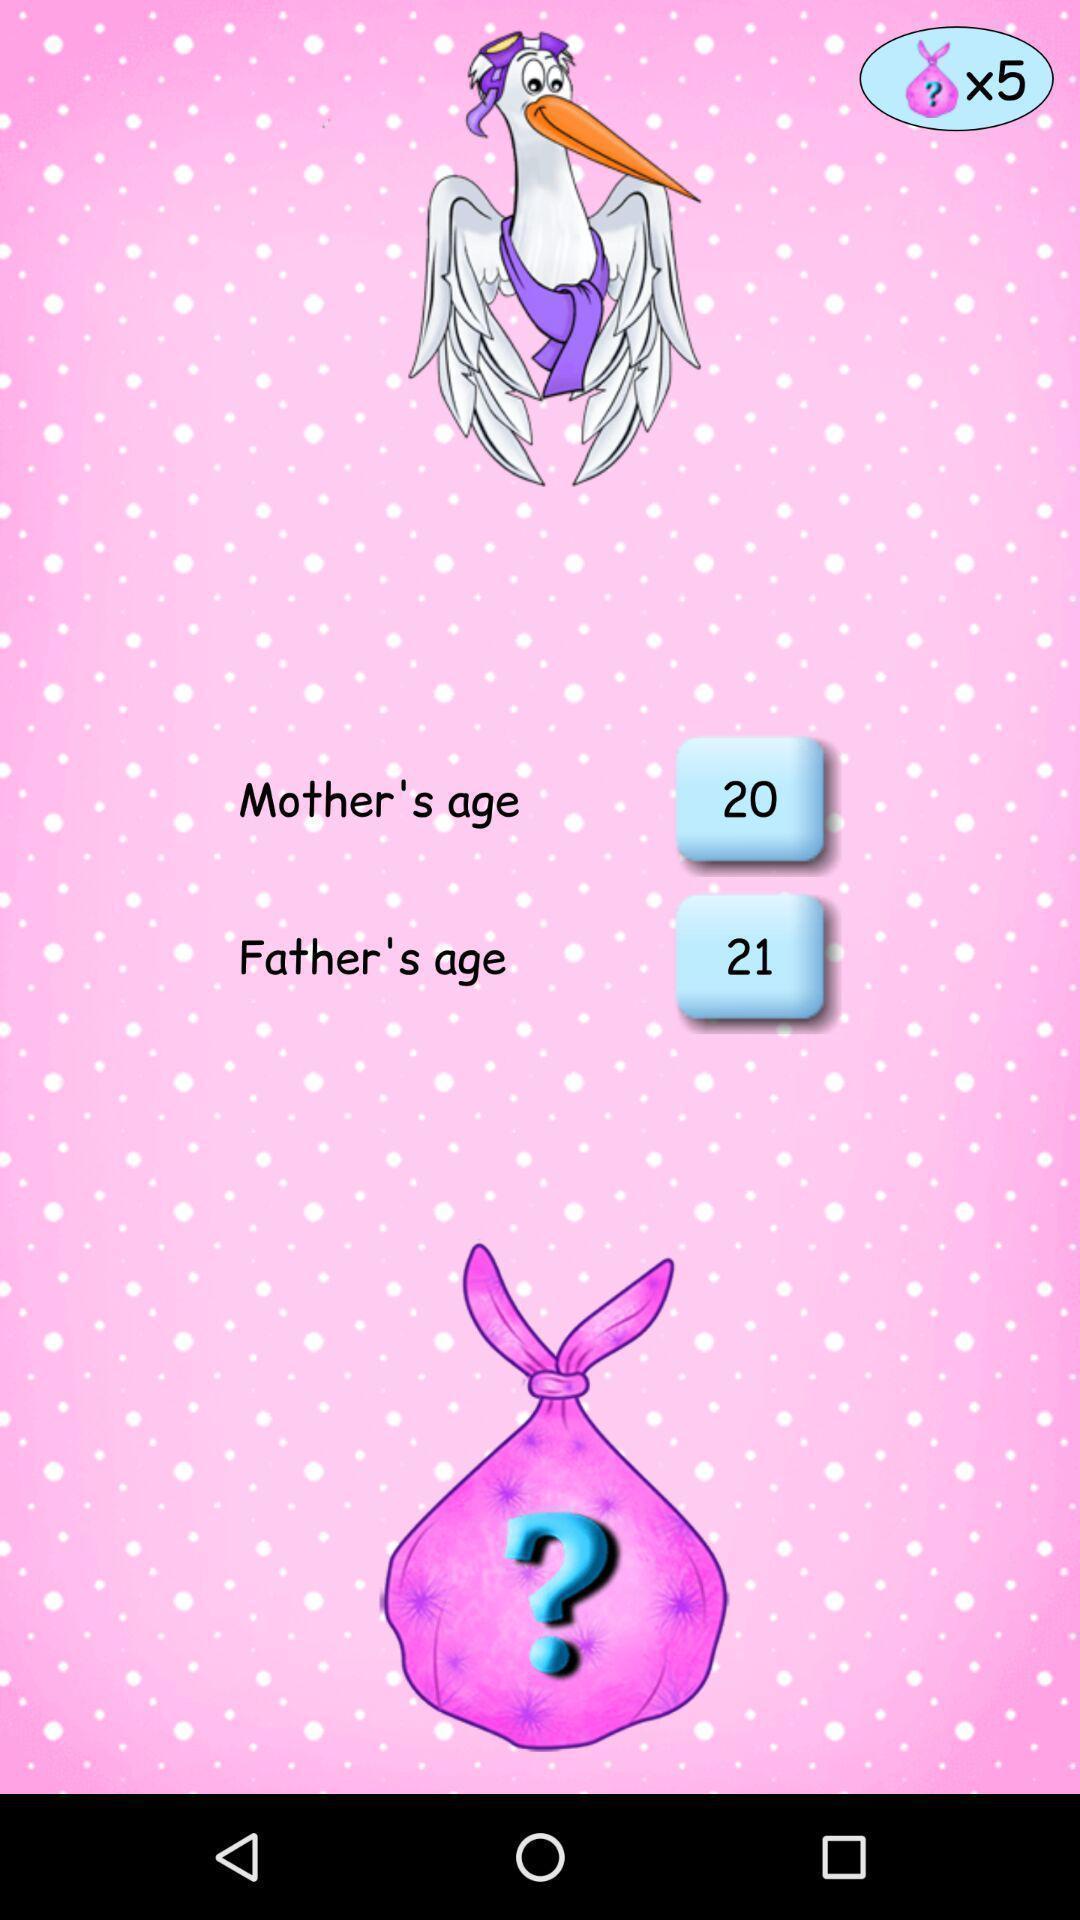Provide a detailed account of this screenshot. Screen displaying the age of mother and father. 